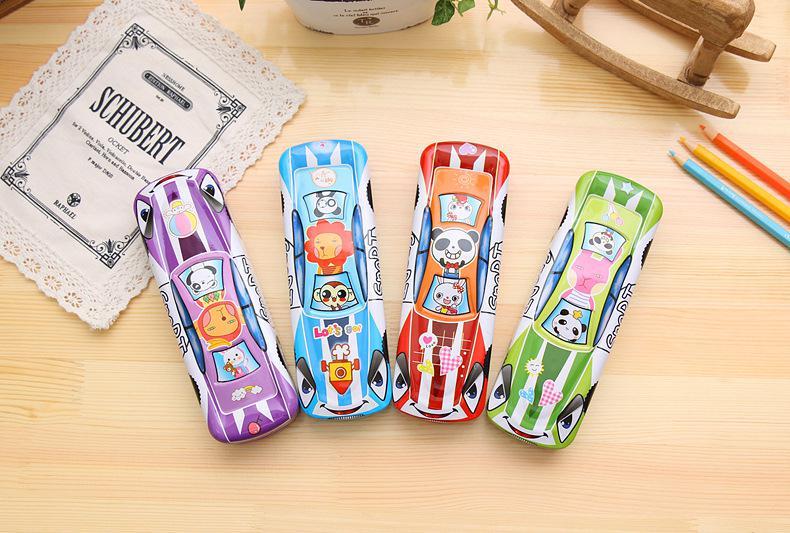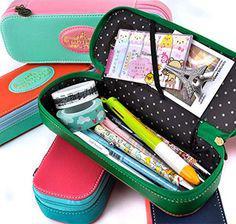The first image is the image on the left, the second image is the image on the right. Analyze the images presented: Is the assertion "At least one image shows an open zipper case with rounded corners and a polka-dotted black interior filled with supplies." valid? Answer yes or no. Yes. The first image is the image on the left, the second image is the image on the right. Considering the images on both sides, is "At least one of the pouches contains an Eiffel tower object." valid? Answer yes or no. Yes. 